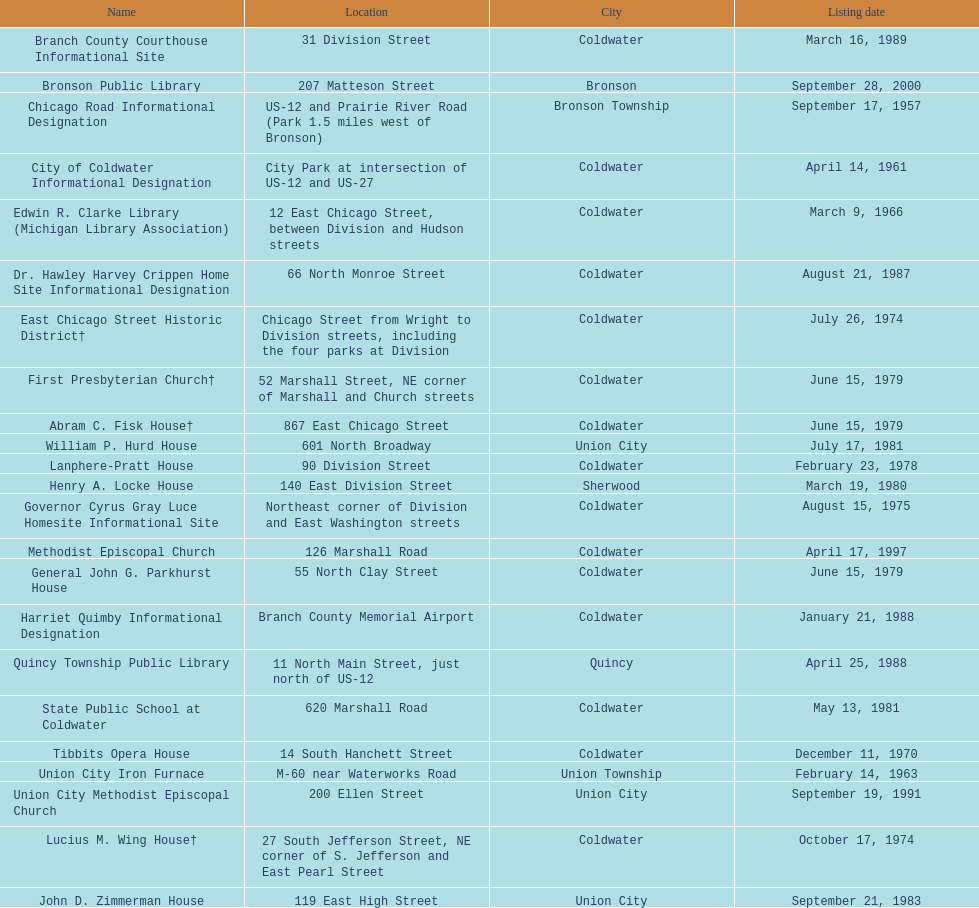What is the total current listing of names on this chart? 23. 